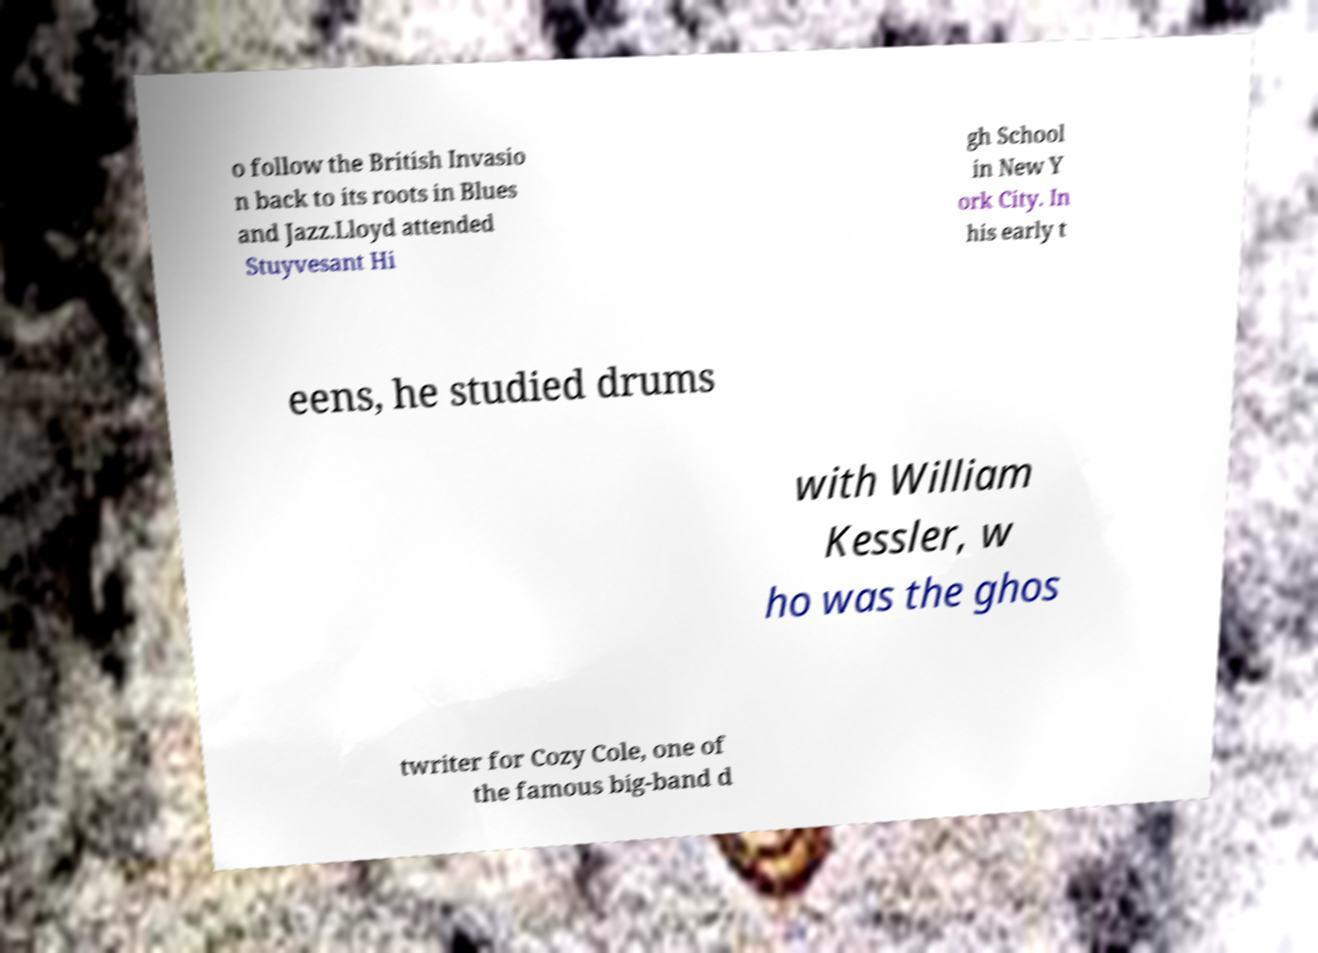Could you assist in decoding the text presented in this image and type it out clearly? o follow the British Invasio n back to its roots in Blues and Jazz.Lloyd attended Stuyvesant Hi gh School in New Y ork City. In his early t eens, he studied drums with William Kessler, w ho was the ghos twriter for Cozy Cole, one of the famous big-band d 